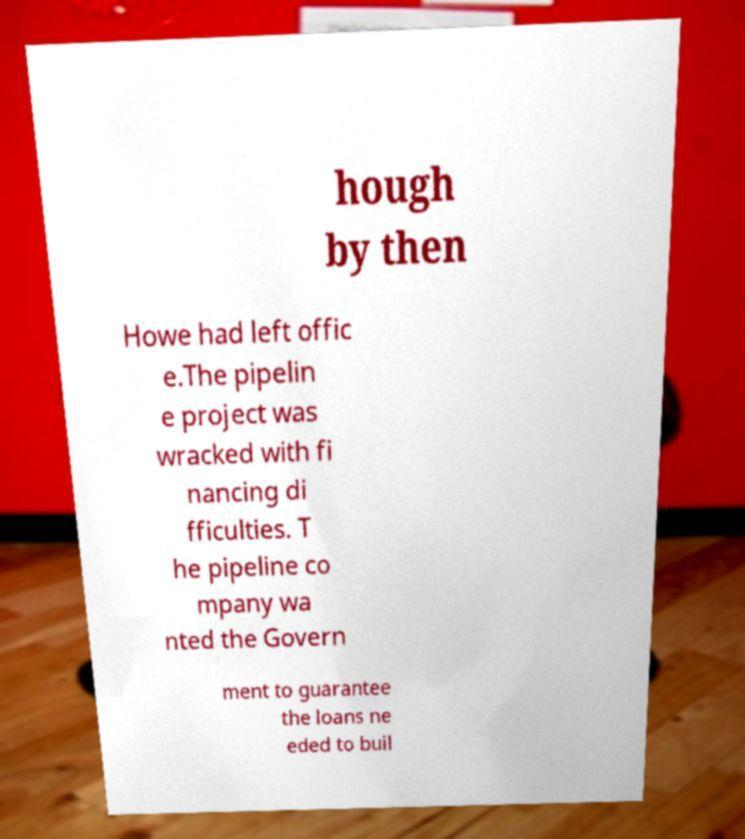What messages or text are displayed in this image? I need them in a readable, typed format. hough by then Howe had left offic e.The pipelin e project was wracked with fi nancing di fficulties. T he pipeline co mpany wa nted the Govern ment to guarantee the loans ne eded to buil 